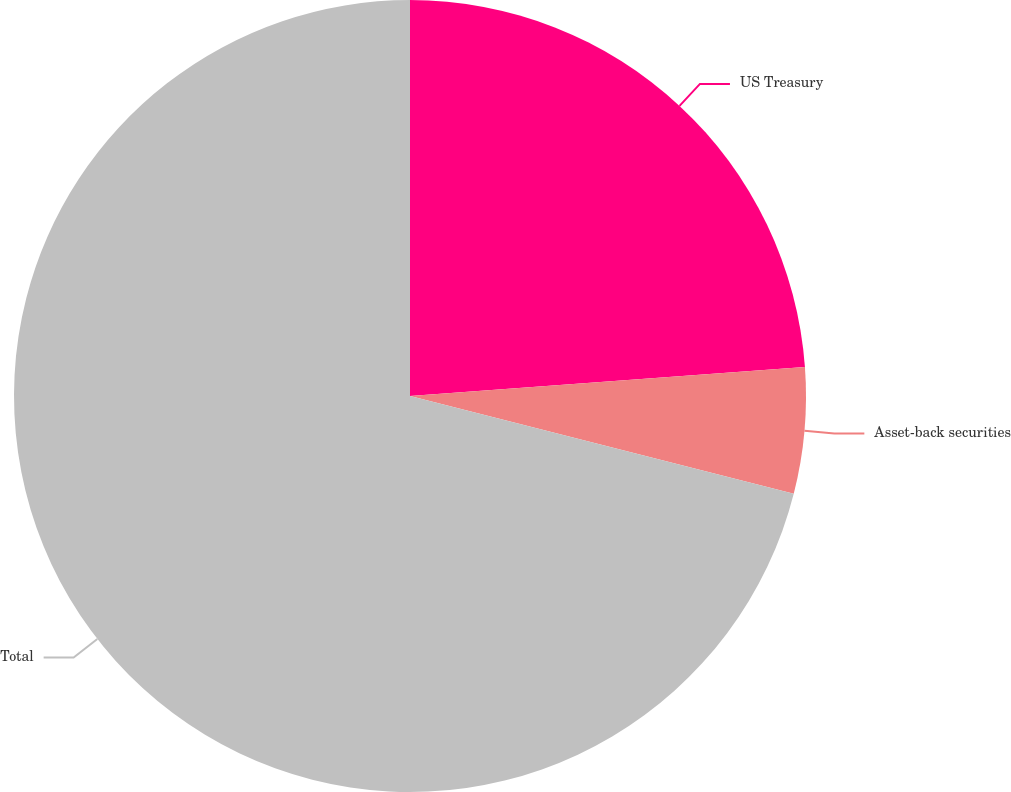<chart> <loc_0><loc_0><loc_500><loc_500><pie_chart><fcel>US Treasury<fcel>Asset-back securities<fcel>Total<nl><fcel>23.83%<fcel>5.14%<fcel>71.03%<nl></chart> 